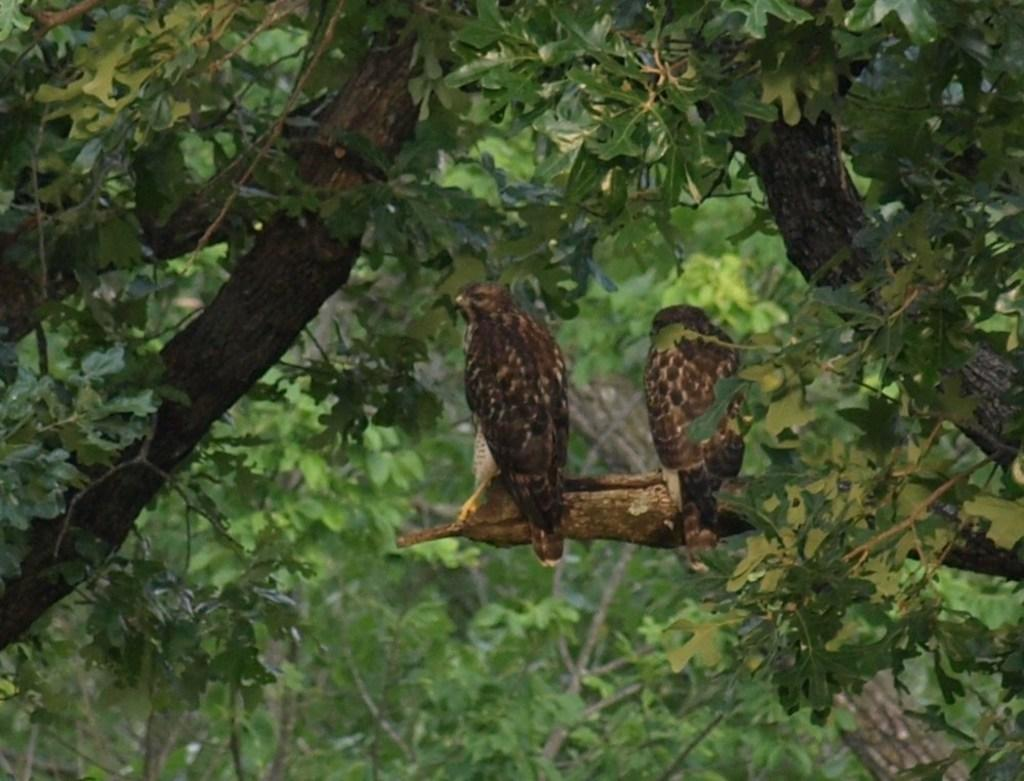What type of vegetation is visible in the image? There are trees in the image. Can you describe the birds in the image? There are two birds on the branch of a tree in the image. What type of milk is being produced by the mind of the bird in the image? There is no indication in the image that the bird has a mind or that it is producing milk. 